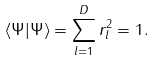<formula> <loc_0><loc_0><loc_500><loc_500>\langle \Psi | \Psi \rangle = \sum _ { l = 1 } ^ { D } r _ { l } ^ { 2 } = 1 .</formula> 